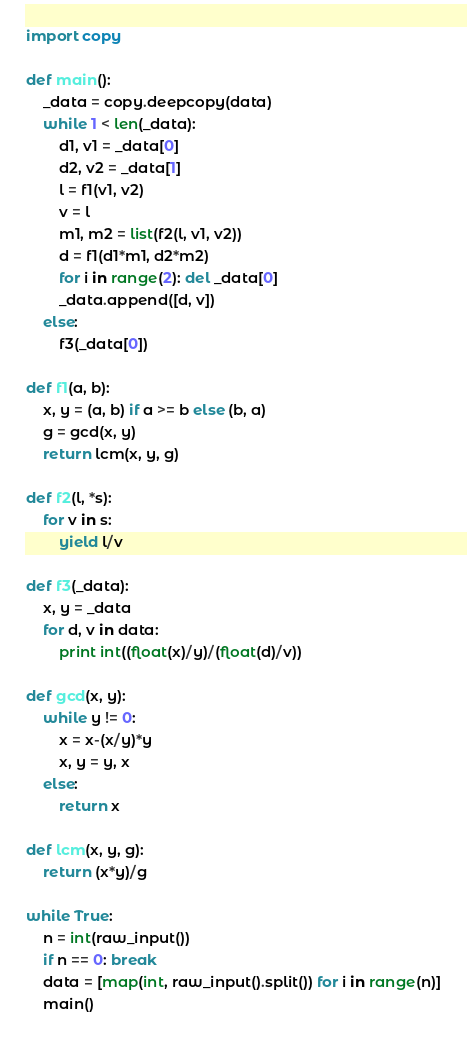Convert code to text. <code><loc_0><loc_0><loc_500><loc_500><_Python_>import copy

def main():
    _data = copy.deepcopy(data)
    while 1 < len(_data):
        d1, v1 = _data[0]
        d2, v2 = _data[1]
        l = f1(v1, v2)
        v = l
        m1, m2 = list(f2(l, v1, v2))
        d = f1(d1*m1, d2*m2)
        for i in range(2): del _data[0]
        _data.append([d, v])
    else:
        f3(_data[0])

def f1(a, b):
    x, y = (a, b) if a >= b else (b, a)
    g = gcd(x, y)
    return lcm(x, y, g)
    
def f2(l, *s):
    for v in s:
        yield l/v
        
def f3(_data):
    x, y = _data
    for d, v in data:
        print int((float(x)/y)/(float(d)/v))
        
def gcd(x, y):
    while y != 0:
        x = x-(x/y)*y
        x, y = y, x
    else:
        return x
    
def lcm(x, y, g):
    return (x*y)/g

while True:
    n = int(raw_input())
    if n == 0: break
    data = [map(int, raw_input().split()) for i in range(n)]
    main()</code> 